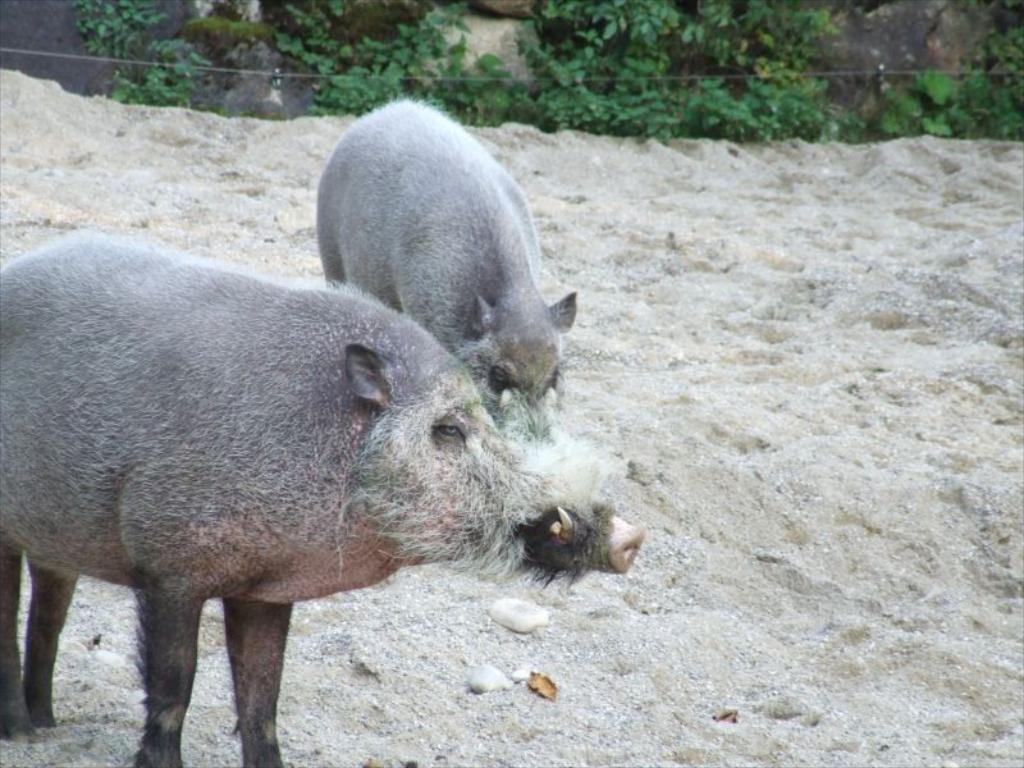What animals are on the ground in the image? There are two pigs on the ground in the image. What can be seen in the background of the image? There are plants and rocks in the background of the image. Can you tell if the image was taken during the day or night? The image was likely taken during the day, as there is no indication of darkness or artificial lighting. Can you see a snake slithering among the plants in the background of the image? There is no snake visible in the image; only the pigs, plants, and rocks can be seen. 